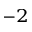Convert formula to latex. <formula><loc_0><loc_0><loc_500><loc_500>^ { - 2 }</formula> 